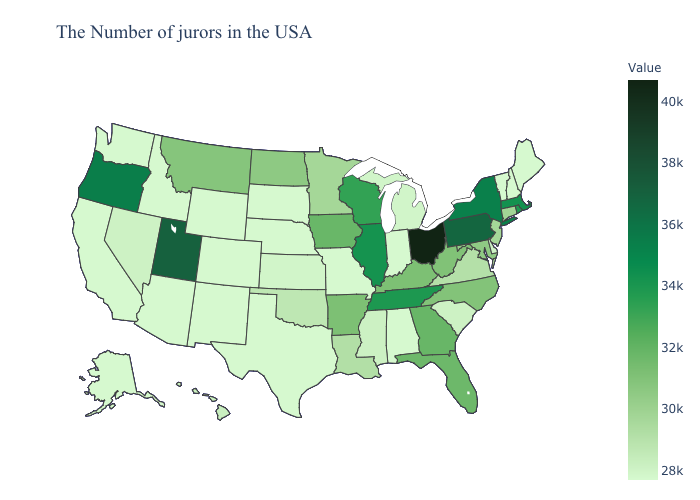Among the states that border Washington , which have the lowest value?
Write a very short answer. Idaho. Does Ohio have a lower value than North Carolina?
Answer briefly. No. Which states have the lowest value in the Northeast?
Give a very brief answer. Maine, New Hampshire, Vermont. Which states have the lowest value in the MidWest?
Answer briefly. Indiana, Missouri, Nebraska, South Dakota. Which states have the highest value in the USA?
Quick response, please. Ohio. Among the states that border Washington , does Oregon have the lowest value?
Give a very brief answer. No. 